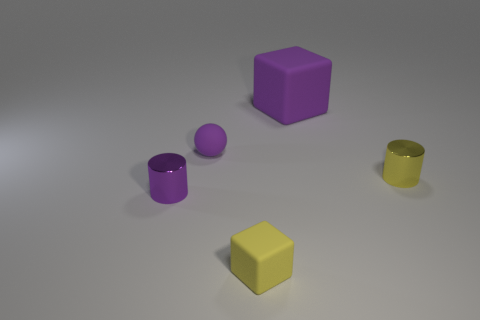Add 1 yellow cylinders. How many objects exist? 6 Subtract all cylinders. How many objects are left? 3 Subtract all small rubber balls. Subtract all large green metal cylinders. How many objects are left? 4 Add 1 small yellow cylinders. How many small yellow cylinders are left? 2 Add 4 large brown spheres. How many large brown spheres exist? 4 Subtract 0 red cylinders. How many objects are left? 5 